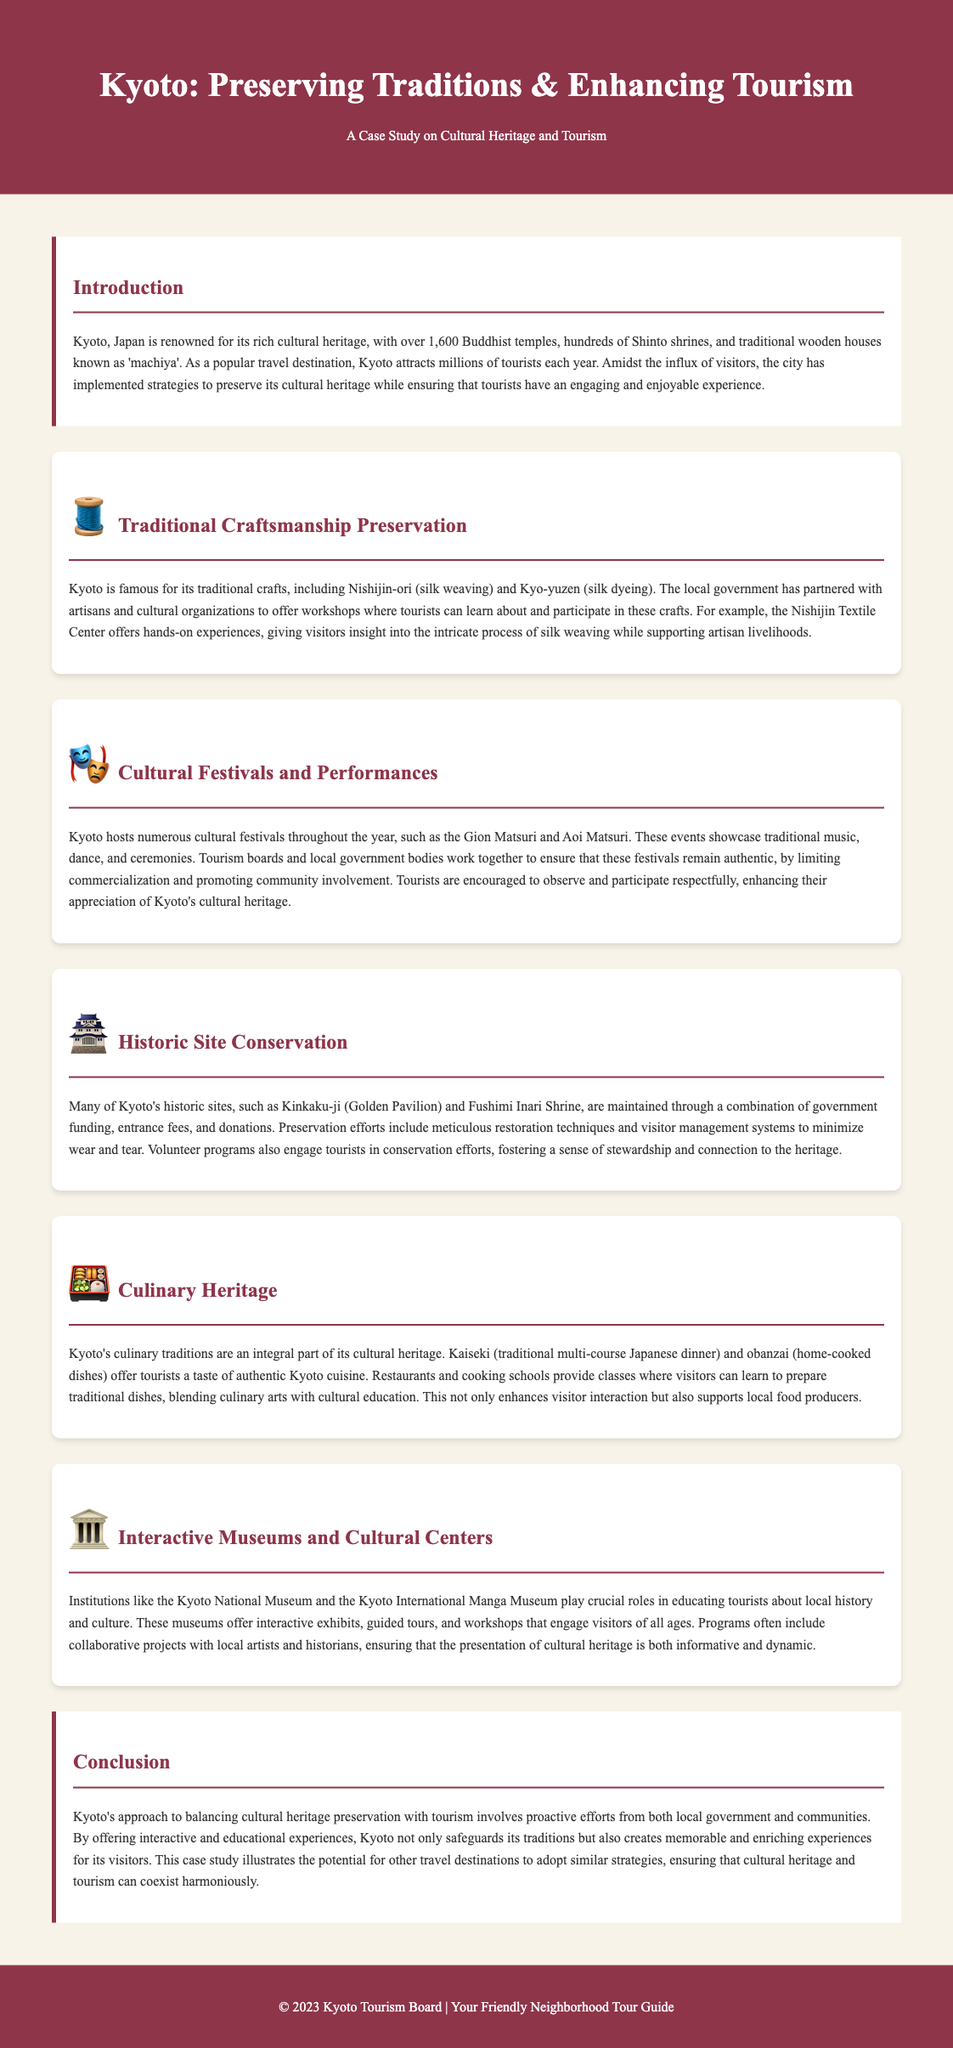What is Kyoto famous for? The document states that Kyoto is renowned for its rich cultural heritage, which includes over 1,600 Buddhist temples and hundreds of Shinto shrines.
Answer: Cultural heritage What traditional craft involves silk weaving? The document mentions Nishijin-ori as the traditional craftsmanship that involves silk weaving.
Answer: Nishijin-ori Which festival is mentioned as an important cultural event in Kyoto? The Gion Matsuri is highlighted as one of the important cultural festivals hosted in Kyoto.
Answer: Gion Matsuri What is the purpose of volunteer programs in historic sites? Volunteer programs engage tourists in conservation efforts, fostering a sense of stewardship and connection to the heritage.
Answer: Conservation efforts What does kaiseki represent in Kyoto's culinary heritage? Kaiseki is described in the document as a traditional multi-course Japanese dinner that reflects Kyoto's culinary traditions.
Answer: Traditional multi-course dinner How does the Kyoto National Museum contribute to tourism? The museum offers interactive exhibits, guided tours, and workshops that educate tourists about local history and culture.
Answer: Education about local history and culture What is a key strategy for preserving cultural heritage in tourism? The document states that proactive efforts from both local government and communities are key strategies for preservation and tourism.
Answer: Proactive efforts How many Buddhist temples does Kyoto have? According to the document, Kyoto has over 1,600 Buddhist temples.
Answer: Over 1,600 What type of workshops does the Nishijin Textile Center offer? The Nishijin Textile Center offers hands-on experiences for tourists to learn about silk weaving.
Answer: Hands-on experiences 